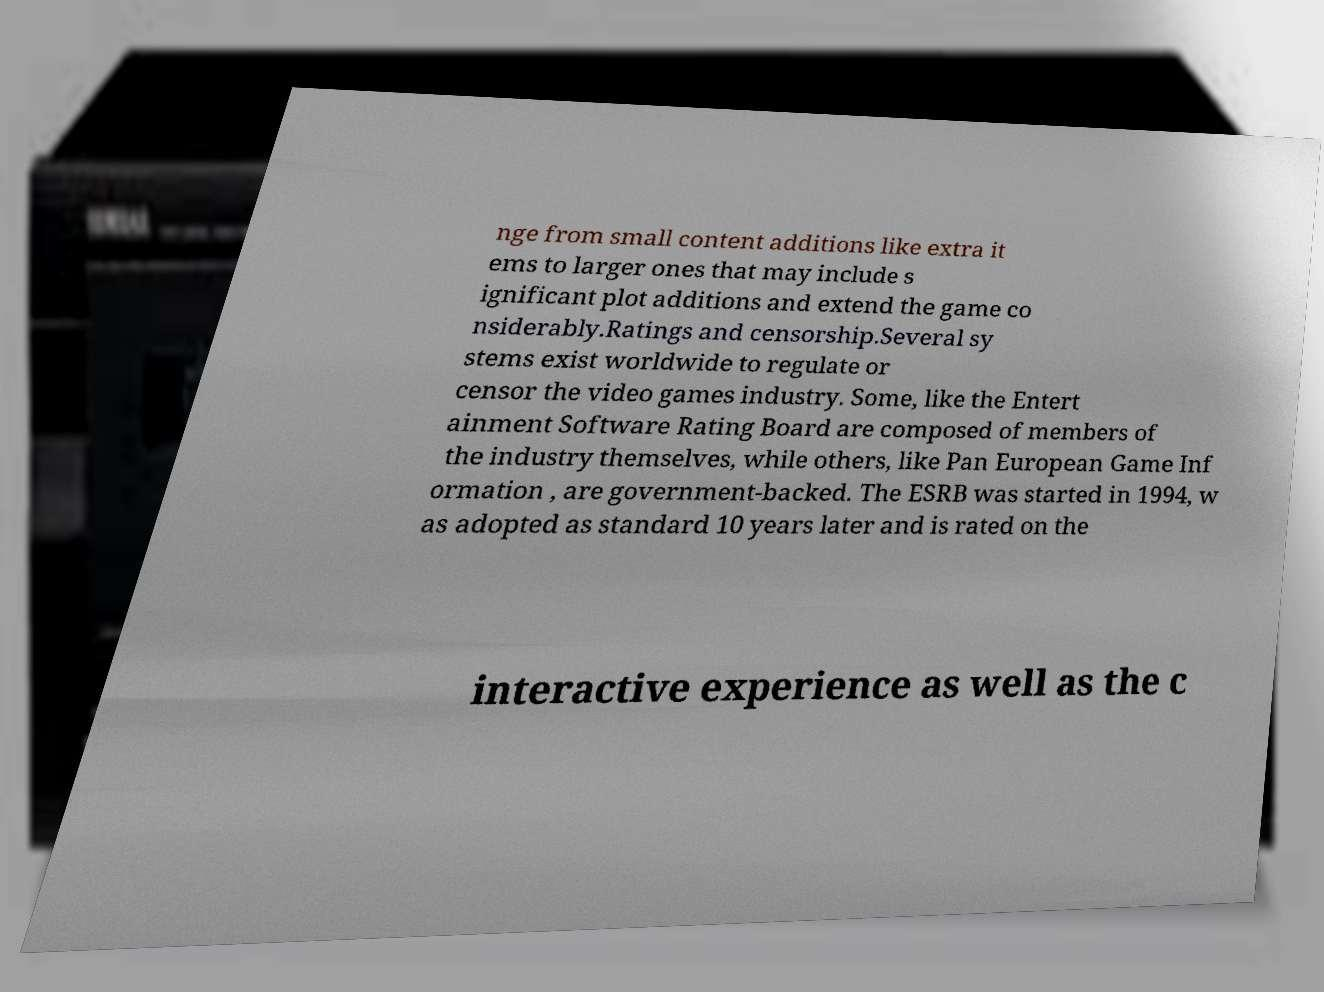What messages or text are displayed in this image? I need them in a readable, typed format. nge from small content additions like extra it ems to larger ones that may include s ignificant plot additions and extend the game co nsiderably.Ratings and censorship.Several sy stems exist worldwide to regulate or censor the video games industry. Some, like the Entert ainment Software Rating Board are composed of members of the industry themselves, while others, like Pan European Game Inf ormation , are government-backed. The ESRB was started in 1994, w as adopted as standard 10 years later and is rated on the interactive experience as well as the c 